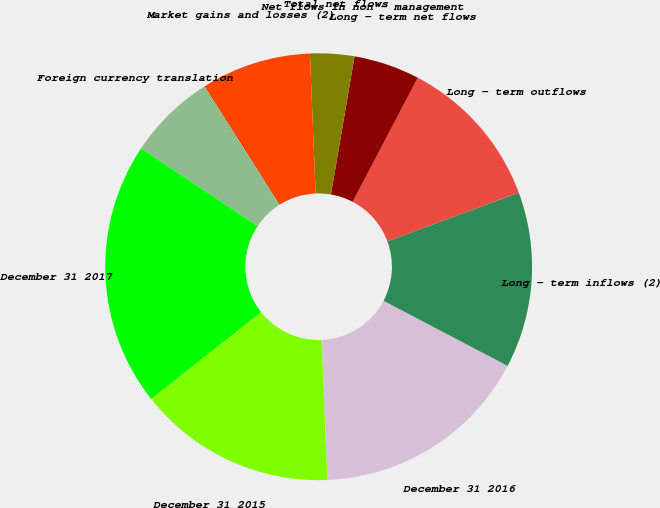<chart> <loc_0><loc_0><loc_500><loc_500><pie_chart><fcel>December 31 2016<fcel>Long - term inflows (2)<fcel>Long - term outflows<fcel>Long - term net flows<fcel>Net flows in non - management<fcel>Total net flows<fcel>Market gains and losses (2)<fcel>Foreign currency translation<fcel>December 31 2017<fcel>December 31 2015<nl><fcel>16.66%<fcel>13.33%<fcel>11.67%<fcel>5.0%<fcel>0.0%<fcel>3.34%<fcel>8.33%<fcel>6.67%<fcel>20.0%<fcel>15.0%<nl></chart> 